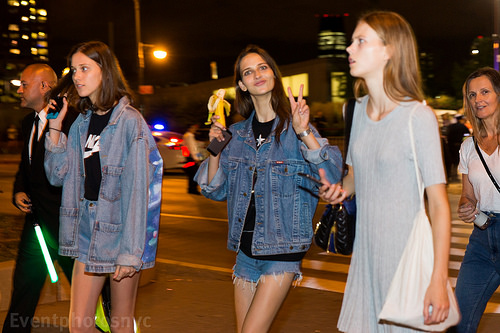<image>
Is there a jacket on the girl? No. The jacket is not positioned on the girl. They may be near each other, but the jacket is not supported by or resting on top of the girl. 